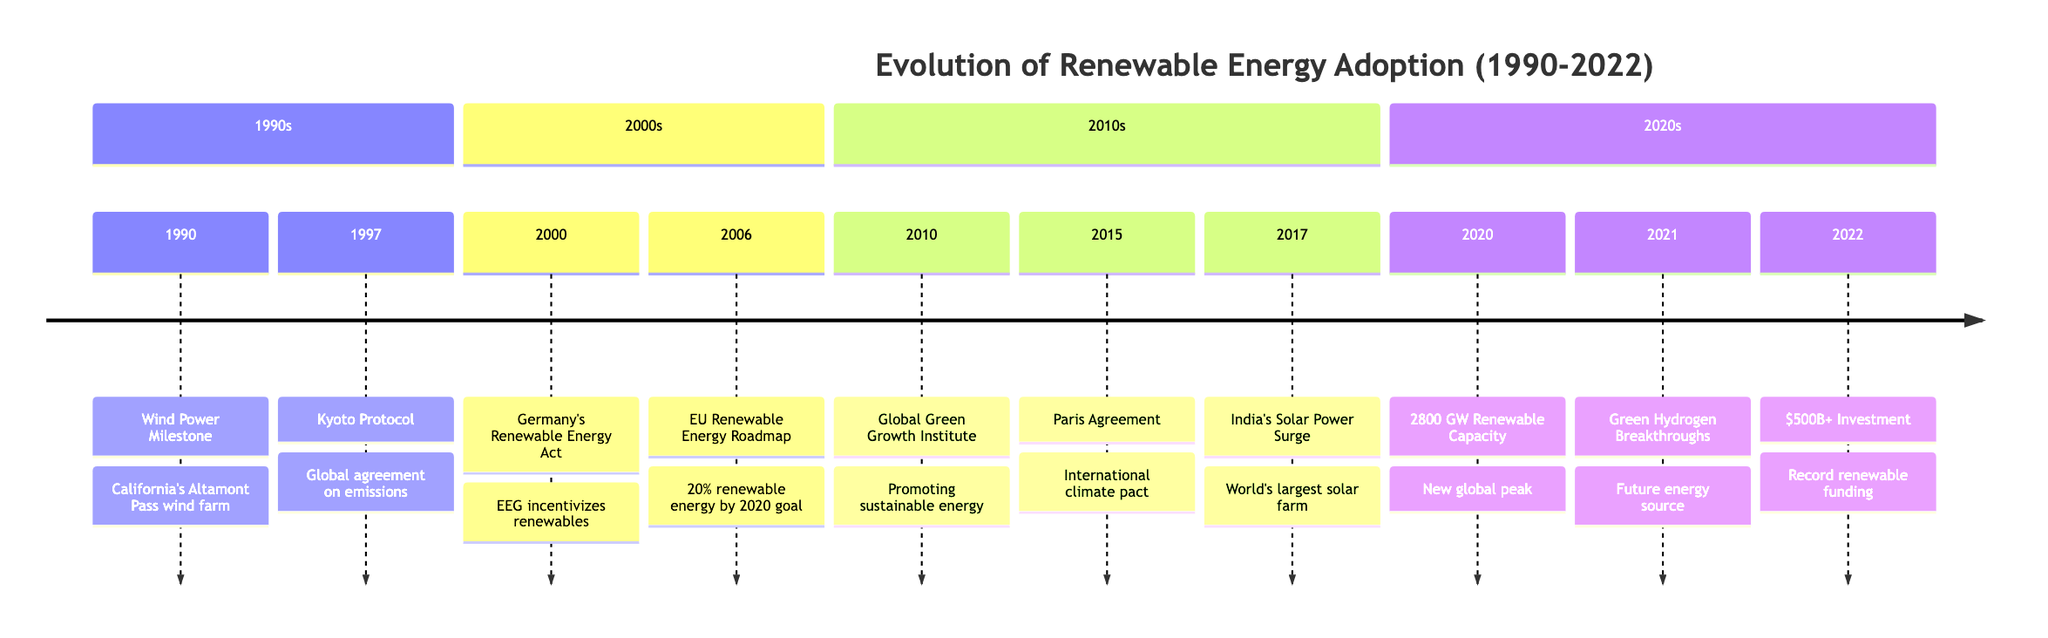What is the earliest event in the timeline? The first event listed in the timeline is from the year 1990, which is the "Wind Power Milestone" marking California's Altamont Pass wind farm.
Answer: Wind Power Milestone How many major milestones are highlighted in the timeline? There are a total of 9 events listed in the timeline, each representing a significant milestone in the evolution of renewable energy adoption.
Answer: 9 What year did the Kyoto Protocol get signed? The Kyoto Protocol is documented in the timeline as having been signed in the year 1997, which is a significant global agreement on emissions.
Answer: 1997 Which event indicates a commitment to renewable energy by various countries? The "Paris Agreement" event in 2015 indicates the commitment of nearly every country to lower carbon emissions and increase renewable energy adoption to combat climate change.
Answer: Paris Agreement What is the landmark event that took place in 2020? The milestone in 2020 that stands out is "Global Renewable Energy Capacity Reaches 2800 GW," indicating a peak in global renewable energy capacity.
Answer: 2800 GW Which two events are related to advancements in renewable energy technologies? The "Launch of the European Union Renewable Energy Roadmap" in 2006 and "Record Investment in Renewables" in 2022 both highlight advancements and commitments towards renewable energy technologies.
Answer: 2006 and 2022 What is significant about the "India's Solar Power Surge" event in 2017? This event signifies India becoming home to the world's largest solar farm, showcasing significant progress in solar energy adoption.
Answer: World's largest solar farm What event did the Global Green Growth Institute initiate? The inception of the Global Green Growth Institute in 2010 is focused on promoting economic growth while reducing carbon emissions and fostering sustainable energy sources globally.
Answer: Global Green Growth Institute What milestone corresponds to over $500 billion investment in renewables? The "Record Investment in Renewables" in 2022 corresponds to the milestone of global investment surpassing $500 billion, indicating a strong commitment to transitioning away from fossil fuels.
Answer: $500B+ Investment 